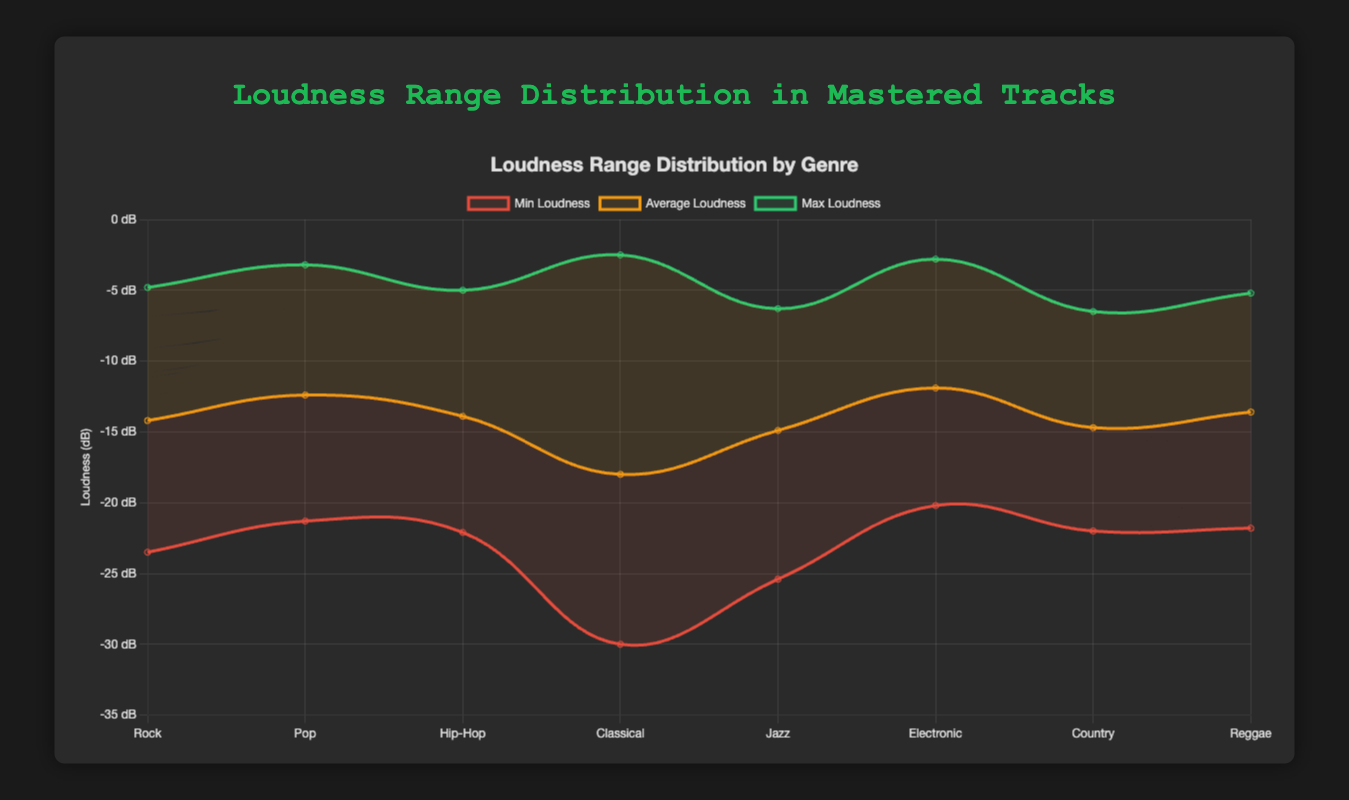Which genre has the highest maximum loudness? The maximum loudness values for each genre are represented by the green line. The Rock genre (specifically, "Bohemian Rhapsody" by Queen) has the highest maximum loudness of -2.5 dB.
Answer: Classical What's the average loudness of Pop tracks? Look at the orange line representing average loudness and find the value for Pop. The average loudness for "Poker Face" by Lady Gaga is -12.4 dB.
Answer: -12.4 dB Which genre shows the widest loudness range between the minimum and maximum values? Calculate the loudness range by subtracting the minimum loudness from the maximum loudness for each genre. Classical has the widest range from -30.0 dB to -2.5 dB, which is a range of 27.5 dB.
Answer: Classical How does the average loudness of Electronic tracks compare to Hip-Hop tracks? Check the orange line for both genres. The average loudness for Electronic ("One More Time") is -11.9 dB, whereas for Hip-Hop ("Lose Yourself") it is -13.9 dB. Electronic is louder on average.
Answer: Electronic is louder What is the minimum loudness value for Country tracks? The red line represents the minimum loudness values. For Country ("Jolene" by Dolly Parton), the minimum loudness is -22.0 dB.
Answer: -22.0 dB Which genre has the smallest difference between average and maximum loudness? Subtract average loudness from maximum loudness for all genres. For Electronic, the difference is -2.8 - (-11.9) = 9.1 dB, which is the smallest such difference among the genres.
Answer: Electronic How does the min loudness of Jazz compare to Reggae? The minimum loudness values are represented by the red line. Jazz ("So What" by Miles Davis) has a minimum loudness of -25.4 dB, whereas Reggae ("Buffalo Soldier" by Bob Marley) has -21.8 dB. Jazz has a lower minimum loudness.
Answer: Jazz has a lower minimum loudness Which genre’s track has the highest range between the average loudness and maximum loudness? Calculate the difference between average and maximum loudness for each genre. The Classical genre shows the largest range from -18.0 dB to -2.5 dB, which is a 15.5 dB difference.
Answer: Classical 